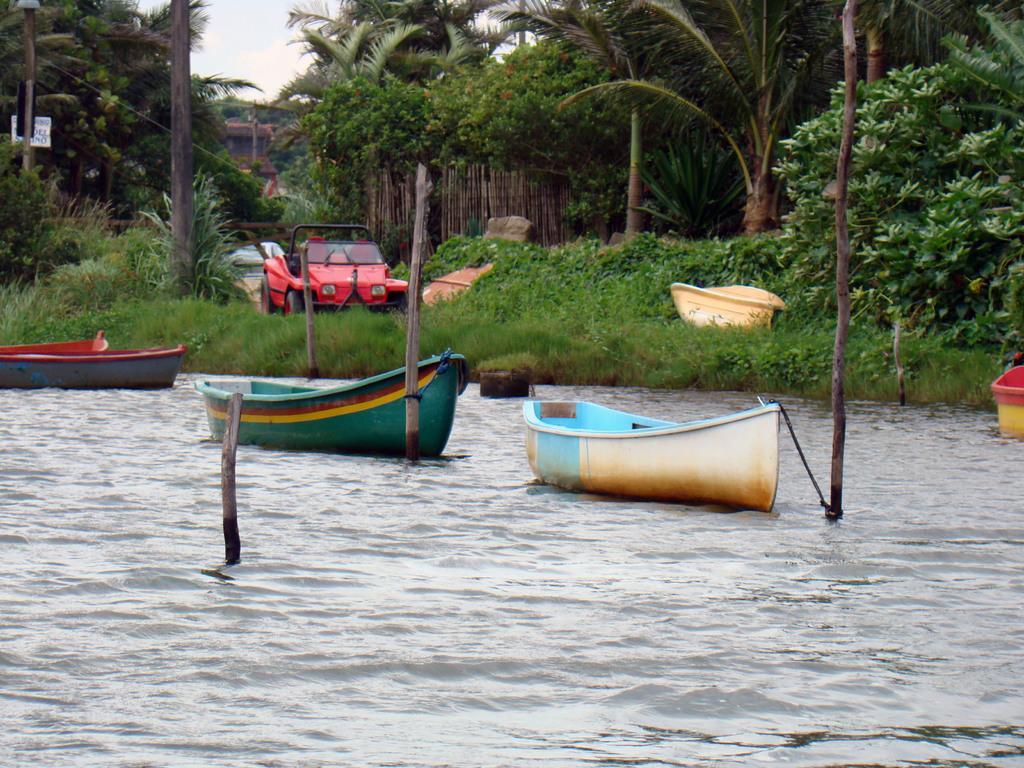In one or two sentences, can you explain what this image depicts? In this image we can see boats on the water, sticks in the water, motor vehicles, shrubs, bushes, trees, wooden fence and sky. 